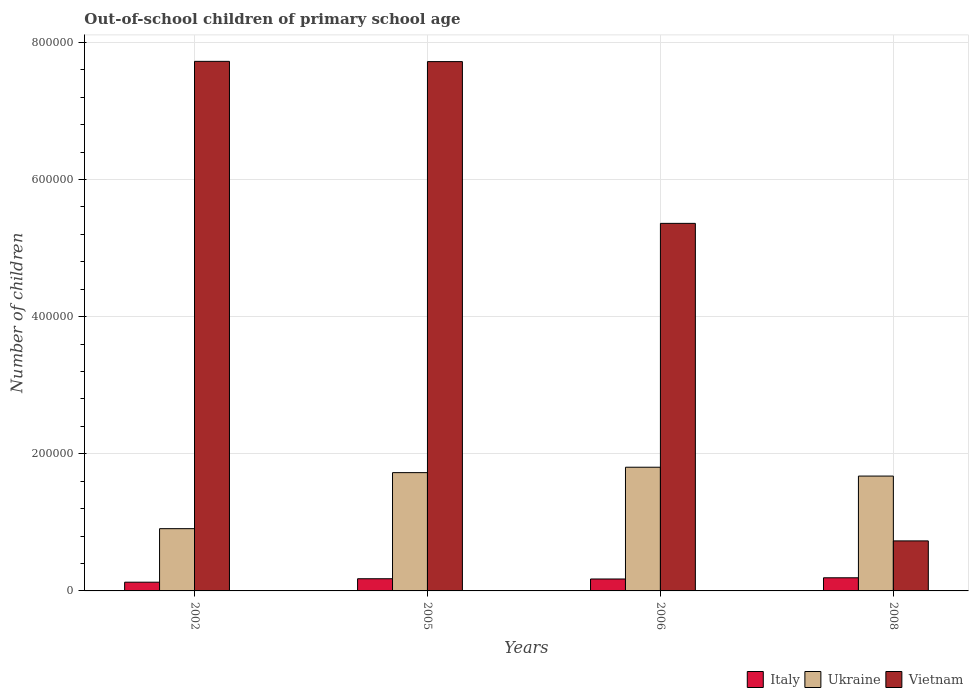Are the number of bars on each tick of the X-axis equal?
Keep it short and to the point. Yes. What is the label of the 2nd group of bars from the left?
Offer a very short reply. 2005. In how many cases, is the number of bars for a given year not equal to the number of legend labels?
Provide a short and direct response. 0. What is the number of out-of-school children in Italy in 2008?
Ensure brevity in your answer.  1.92e+04. Across all years, what is the maximum number of out-of-school children in Ukraine?
Your response must be concise. 1.80e+05. Across all years, what is the minimum number of out-of-school children in Italy?
Give a very brief answer. 1.27e+04. In which year was the number of out-of-school children in Italy maximum?
Offer a terse response. 2008. In which year was the number of out-of-school children in Italy minimum?
Provide a short and direct response. 2002. What is the total number of out-of-school children in Ukraine in the graph?
Provide a succinct answer. 6.11e+05. What is the difference between the number of out-of-school children in Italy in 2002 and that in 2006?
Provide a short and direct response. -4674. What is the difference between the number of out-of-school children in Ukraine in 2008 and the number of out-of-school children in Vietnam in 2005?
Keep it short and to the point. -6.04e+05. What is the average number of out-of-school children in Vietnam per year?
Make the answer very short. 5.38e+05. In the year 2002, what is the difference between the number of out-of-school children in Italy and number of out-of-school children in Vietnam?
Offer a terse response. -7.60e+05. In how many years, is the number of out-of-school children in Ukraine greater than 200000?
Ensure brevity in your answer.  0. What is the ratio of the number of out-of-school children in Ukraine in 2006 to that in 2008?
Offer a very short reply. 1.08. Is the difference between the number of out-of-school children in Italy in 2002 and 2006 greater than the difference between the number of out-of-school children in Vietnam in 2002 and 2006?
Ensure brevity in your answer.  No. What is the difference between the highest and the second highest number of out-of-school children in Italy?
Provide a short and direct response. 1390. What is the difference between the highest and the lowest number of out-of-school children in Ukraine?
Provide a short and direct response. 8.96e+04. In how many years, is the number of out-of-school children in Ukraine greater than the average number of out-of-school children in Ukraine taken over all years?
Make the answer very short. 3. What does the 2nd bar from the left in 2008 represents?
Keep it short and to the point. Ukraine. What does the 2nd bar from the right in 2008 represents?
Offer a terse response. Ukraine. Are all the bars in the graph horizontal?
Provide a short and direct response. No. How many years are there in the graph?
Provide a succinct answer. 4. Are the values on the major ticks of Y-axis written in scientific E-notation?
Provide a succinct answer. No. Does the graph contain any zero values?
Provide a short and direct response. No. How are the legend labels stacked?
Offer a very short reply. Horizontal. What is the title of the graph?
Your answer should be very brief. Out-of-school children of primary school age. What is the label or title of the X-axis?
Provide a short and direct response. Years. What is the label or title of the Y-axis?
Give a very brief answer. Number of children. What is the Number of children in Italy in 2002?
Your answer should be very brief. 1.27e+04. What is the Number of children in Ukraine in 2002?
Ensure brevity in your answer.  9.08e+04. What is the Number of children of Vietnam in 2002?
Your answer should be compact. 7.72e+05. What is the Number of children of Italy in 2005?
Your answer should be very brief. 1.78e+04. What is the Number of children in Ukraine in 2005?
Your answer should be very brief. 1.73e+05. What is the Number of children of Vietnam in 2005?
Your answer should be very brief. 7.72e+05. What is the Number of children in Italy in 2006?
Keep it short and to the point. 1.74e+04. What is the Number of children in Ukraine in 2006?
Provide a short and direct response. 1.80e+05. What is the Number of children in Vietnam in 2006?
Your answer should be compact. 5.36e+05. What is the Number of children in Italy in 2008?
Give a very brief answer. 1.92e+04. What is the Number of children in Ukraine in 2008?
Ensure brevity in your answer.  1.67e+05. What is the Number of children in Vietnam in 2008?
Provide a short and direct response. 7.30e+04. Across all years, what is the maximum Number of children in Italy?
Give a very brief answer. 1.92e+04. Across all years, what is the maximum Number of children in Ukraine?
Keep it short and to the point. 1.80e+05. Across all years, what is the maximum Number of children of Vietnam?
Make the answer very short. 7.72e+05. Across all years, what is the minimum Number of children of Italy?
Make the answer very short. 1.27e+04. Across all years, what is the minimum Number of children in Ukraine?
Provide a short and direct response. 9.08e+04. Across all years, what is the minimum Number of children of Vietnam?
Ensure brevity in your answer.  7.30e+04. What is the total Number of children of Italy in the graph?
Give a very brief answer. 6.70e+04. What is the total Number of children in Ukraine in the graph?
Your answer should be compact. 6.11e+05. What is the total Number of children of Vietnam in the graph?
Offer a very short reply. 2.15e+06. What is the difference between the Number of children in Italy in 2002 and that in 2005?
Your answer should be very brief. -5049. What is the difference between the Number of children of Ukraine in 2002 and that in 2005?
Offer a very short reply. -8.17e+04. What is the difference between the Number of children in Vietnam in 2002 and that in 2005?
Your response must be concise. 360. What is the difference between the Number of children of Italy in 2002 and that in 2006?
Make the answer very short. -4674. What is the difference between the Number of children in Ukraine in 2002 and that in 2006?
Keep it short and to the point. -8.96e+04. What is the difference between the Number of children of Vietnam in 2002 and that in 2006?
Your answer should be compact. 2.36e+05. What is the difference between the Number of children of Italy in 2002 and that in 2008?
Your answer should be very brief. -6439. What is the difference between the Number of children in Ukraine in 2002 and that in 2008?
Keep it short and to the point. -7.67e+04. What is the difference between the Number of children of Vietnam in 2002 and that in 2008?
Ensure brevity in your answer.  6.99e+05. What is the difference between the Number of children of Italy in 2005 and that in 2006?
Make the answer very short. 375. What is the difference between the Number of children of Ukraine in 2005 and that in 2006?
Provide a succinct answer. -7864. What is the difference between the Number of children of Vietnam in 2005 and that in 2006?
Your answer should be compact. 2.36e+05. What is the difference between the Number of children in Italy in 2005 and that in 2008?
Provide a short and direct response. -1390. What is the difference between the Number of children in Ukraine in 2005 and that in 2008?
Offer a terse response. 5031. What is the difference between the Number of children of Vietnam in 2005 and that in 2008?
Your response must be concise. 6.99e+05. What is the difference between the Number of children in Italy in 2006 and that in 2008?
Keep it short and to the point. -1765. What is the difference between the Number of children in Ukraine in 2006 and that in 2008?
Your answer should be compact. 1.29e+04. What is the difference between the Number of children in Vietnam in 2006 and that in 2008?
Ensure brevity in your answer.  4.63e+05. What is the difference between the Number of children of Italy in 2002 and the Number of children of Ukraine in 2005?
Offer a terse response. -1.60e+05. What is the difference between the Number of children in Italy in 2002 and the Number of children in Vietnam in 2005?
Your answer should be compact. -7.59e+05. What is the difference between the Number of children of Ukraine in 2002 and the Number of children of Vietnam in 2005?
Your answer should be compact. -6.81e+05. What is the difference between the Number of children of Italy in 2002 and the Number of children of Ukraine in 2006?
Keep it short and to the point. -1.68e+05. What is the difference between the Number of children of Italy in 2002 and the Number of children of Vietnam in 2006?
Give a very brief answer. -5.23e+05. What is the difference between the Number of children of Ukraine in 2002 and the Number of children of Vietnam in 2006?
Offer a very short reply. -4.45e+05. What is the difference between the Number of children in Italy in 2002 and the Number of children in Ukraine in 2008?
Your answer should be very brief. -1.55e+05. What is the difference between the Number of children of Italy in 2002 and the Number of children of Vietnam in 2008?
Provide a short and direct response. -6.02e+04. What is the difference between the Number of children in Ukraine in 2002 and the Number of children in Vietnam in 2008?
Provide a short and direct response. 1.78e+04. What is the difference between the Number of children in Italy in 2005 and the Number of children in Ukraine in 2006?
Give a very brief answer. -1.63e+05. What is the difference between the Number of children in Italy in 2005 and the Number of children in Vietnam in 2006?
Make the answer very short. -5.18e+05. What is the difference between the Number of children in Ukraine in 2005 and the Number of children in Vietnam in 2006?
Your answer should be very brief. -3.64e+05. What is the difference between the Number of children in Italy in 2005 and the Number of children in Ukraine in 2008?
Provide a succinct answer. -1.50e+05. What is the difference between the Number of children in Italy in 2005 and the Number of children in Vietnam in 2008?
Your response must be concise. -5.52e+04. What is the difference between the Number of children in Ukraine in 2005 and the Number of children in Vietnam in 2008?
Make the answer very short. 9.96e+04. What is the difference between the Number of children in Italy in 2006 and the Number of children in Ukraine in 2008?
Provide a short and direct response. -1.50e+05. What is the difference between the Number of children of Italy in 2006 and the Number of children of Vietnam in 2008?
Give a very brief answer. -5.56e+04. What is the difference between the Number of children of Ukraine in 2006 and the Number of children of Vietnam in 2008?
Your response must be concise. 1.07e+05. What is the average Number of children of Italy per year?
Your answer should be compact. 1.68e+04. What is the average Number of children of Ukraine per year?
Keep it short and to the point. 1.53e+05. What is the average Number of children of Vietnam per year?
Give a very brief answer. 5.38e+05. In the year 2002, what is the difference between the Number of children in Italy and Number of children in Ukraine?
Provide a succinct answer. -7.81e+04. In the year 2002, what is the difference between the Number of children of Italy and Number of children of Vietnam?
Offer a terse response. -7.60e+05. In the year 2002, what is the difference between the Number of children of Ukraine and Number of children of Vietnam?
Keep it short and to the point. -6.81e+05. In the year 2005, what is the difference between the Number of children in Italy and Number of children in Ukraine?
Offer a terse response. -1.55e+05. In the year 2005, what is the difference between the Number of children of Italy and Number of children of Vietnam?
Give a very brief answer. -7.54e+05. In the year 2005, what is the difference between the Number of children in Ukraine and Number of children in Vietnam?
Provide a short and direct response. -5.99e+05. In the year 2006, what is the difference between the Number of children in Italy and Number of children in Ukraine?
Provide a succinct answer. -1.63e+05. In the year 2006, what is the difference between the Number of children of Italy and Number of children of Vietnam?
Your answer should be compact. -5.19e+05. In the year 2006, what is the difference between the Number of children in Ukraine and Number of children in Vietnam?
Ensure brevity in your answer.  -3.56e+05. In the year 2008, what is the difference between the Number of children of Italy and Number of children of Ukraine?
Your answer should be compact. -1.48e+05. In the year 2008, what is the difference between the Number of children in Italy and Number of children in Vietnam?
Give a very brief answer. -5.38e+04. In the year 2008, what is the difference between the Number of children of Ukraine and Number of children of Vietnam?
Make the answer very short. 9.45e+04. What is the ratio of the Number of children in Italy in 2002 to that in 2005?
Provide a succinct answer. 0.72. What is the ratio of the Number of children of Ukraine in 2002 to that in 2005?
Ensure brevity in your answer.  0.53. What is the ratio of the Number of children of Vietnam in 2002 to that in 2005?
Offer a very short reply. 1. What is the ratio of the Number of children in Italy in 2002 to that in 2006?
Provide a short and direct response. 0.73. What is the ratio of the Number of children in Ukraine in 2002 to that in 2006?
Offer a terse response. 0.5. What is the ratio of the Number of children in Vietnam in 2002 to that in 2006?
Offer a very short reply. 1.44. What is the ratio of the Number of children of Italy in 2002 to that in 2008?
Offer a terse response. 0.66. What is the ratio of the Number of children of Ukraine in 2002 to that in 2008?
Give a very brief answer. 0.54. What is the ratio of the Number of children of Vietnam in 2002 to that in 2008?
Your answer should be compact. 10.59. What is the ratio of the Number of children in Italy in 2005 to that in 2006?
Give a very brief answer. 1.02. What is the ratio of the Number of children in Ukraine in 2005 to that in 2006?
Give a very brief answer. 0.96. What is the ratio of the Number of children of Vietnam in 2005 to that in 2006?
Your answer should be very brief. 1.44. What is the ratio of the Number of children in Italy in 2005 to that in 2008?
Offer a very short reply. 0.93. What is the ratio of the Number of children of Vietnam in 2005 to that in 2008?
Give a very brief answer. 10.58. What is the ratio of the Number of children in Italy in 2006 to that in 2008?
Ensure brevity in your answer.  0.91. What is the ratio of the Number of children of Ukraine in 2006 to that in 2008?
Provide a succinct answer. 1.08. What is the ratio of the Number of children in Vietnam in 2006 to that in 2008?
Your response must be concise. 7.35. What is the difference between the highest and the second highest Number of children in Italy?
Provide a succinct answer. 1390. What is the difference between the highest and the second highest Number of children in Ukraine?
Provide a short and direct response. 7864. What is the difference between the highest and the second highest Number of children of Vietnam?
Give a very brief answer. 360. What is the difference between the highest and the lowest Number of children of Italy?
Your answer should be compact. 6439. What is the difference between the highest and the lowest Number of children of Ukraine?
Make the answer very short. 8.96e+04. What is the difference between the highest and the lowest Number of children in Vietnam?
Keep it short and to the point. 6.99e+05. 